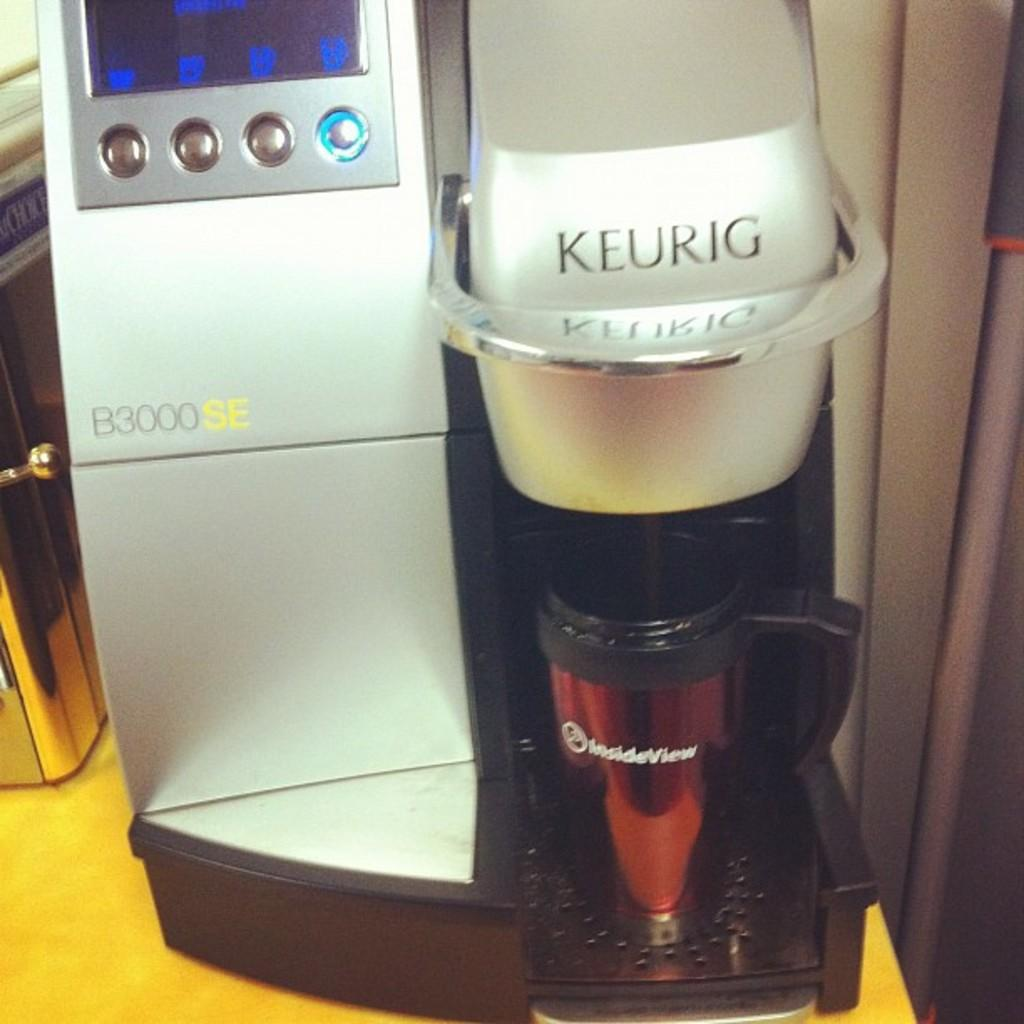<image>
Provide a brief description of the given image. A red travel mug sits under the spout of a Keurig coffee maker. 